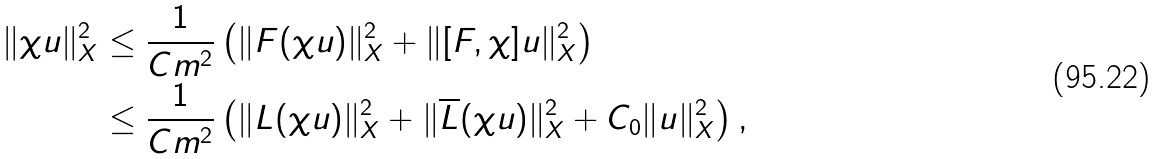Convert formula to latex. <formula><loc_0><loc_0><loc_500><loc_500>\| \chi u \| _ { X } ^ { 2 } & \leq \frac { 1 } { C m ^ { 2 } } \left ( \| F ( \chi u ) \| _ { X } ^ { 2 } + \| [ F , \chi ] u \| _ { X } ^ { 2 } \right ) \\ & \leq \frac { 1 } { C m ^ { 2 } } \left ( \| L ( \chi u ) \| _ { X } ^ { 2 } + \| \overline { L } ( \chi u ) \| _ { X } ^ { 2 } + C _ { 0 } \| u \| _ { X } ^ { 2 } \right ) ,</formula> 